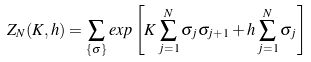Convert formula to latex. <formula><loc_0><loc_0><loc_500><loc_500>Z _ { N } ( K , h ) = \sum _ { \{ \sigma \} } e x p \left [ { K \sum _ { j = 1 } ^ { N } \sigma _ { j } \sigma _ { j + 1 } + h \sum _ { j = 1 } ^ { N } \sigma _ { j } } \right ]</formula> 